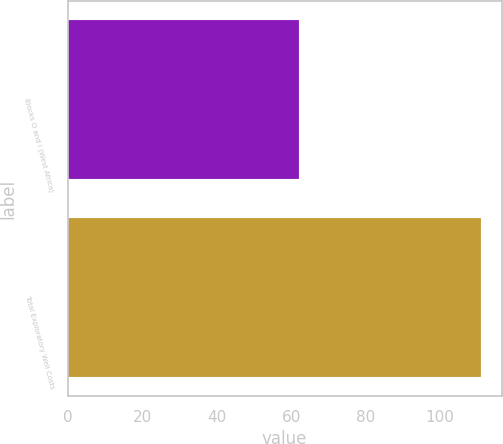<chart> <loc_0><loc_0><loc_500><loc_500><bar_chart><fcel>Blocks O and I (West Africa)<fcel>Total Exploratory Well Costs<nl><fcel>62<fcel>111<nl></chart> 